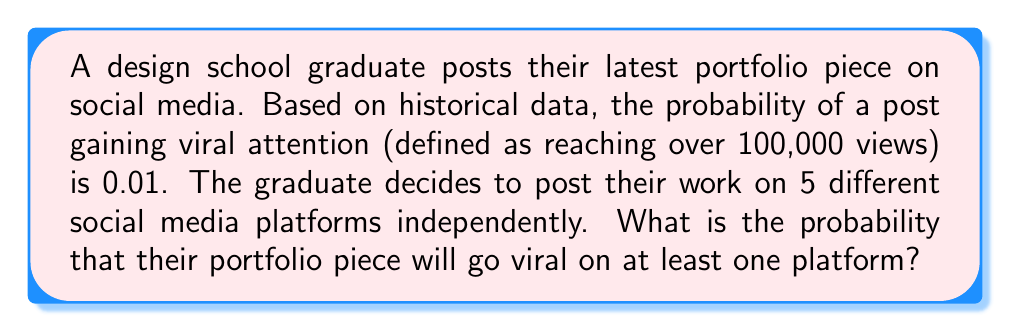What is the answer to this math problem? Let's approach this step-by-step:

1) First, let's define our events:
   Let $A_i$ be the event that the post goes viral on platform $i$, where $i = 1, 2, 3, 4, 5$.

2) We're given that $P(A_i) = 0.01$ for each platform.

3) We want to find the probability of the post going viral on at least one platform. It's easier to calculate the complement of this event: the probability that the post doesn't go viral on any platform.

4) The probability of the post not going viral on a single platform is:
   $P(\text{not }A_i) = 1 - P(A_i) = 1 - 0.01 = 0.99$

5) Since the posts are independent, we can multiply these probabilities:
   $P(\text{not viral on any platform}) = 0.99^5 = 0.9509795$

6) Therefore, the probability of going viral on at least one platform is:
   $P(\text{viral on at least one}) = 1 - P(\text{not viral on any}) = 1 - 0.9509795 = 0.0490205$

7) We can express this as a percentage: $0.0490205 \times 100\% = 4.90205\%$
Answer: $0.0490205$ or $4.90205\%$ 